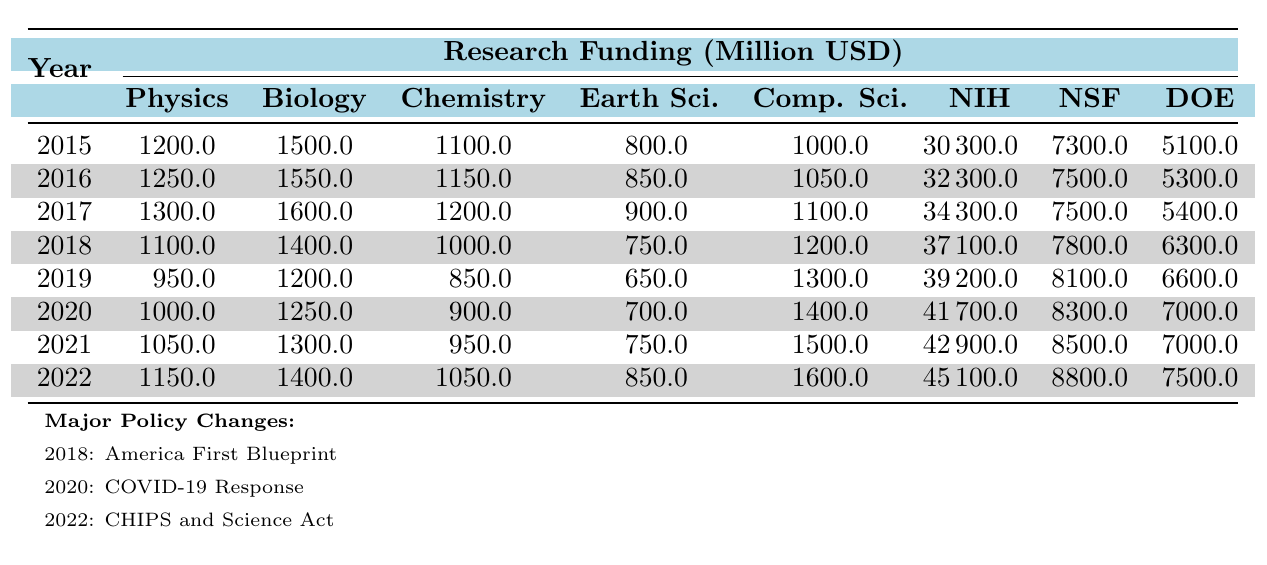What was the funding for Biology in 2020? In the table, the value for Biology Funding in 2020 is 1250 million USD.
Answer: 1250 million USD Which discipline received the highest funding in 2019? By comparing the funding values for 2019, Biology (1200 million USD) received the highest funding compared to other disciplines.
Answer: Biology What is the difference in funding for Physics between 2015 and 2022? The funding for Physics in 2015 was 1200 million USD, and in 2022 it was 1150 million USD. The difference is 1200 - 1150 = 50 million USD.
Answer: 50 million USD What was the average funding for Computer Science from 2015 to 2022? The total funding for Computer Science over these years is 1000 + 1050 + 1100 + 1200 + 1300 + 1400 + 1500 + 1600 = 10500 million USD. There are 8 years, so the average is 10500 / 8 = 1312.5 million USD.
Answer: 1312.5 million USD Did the funding for Earth Sciences increase from 2015 to 2022? In 2015, funding was 800 million USD, and in 2022 it was 850 million USD. Since 850 > 800, the funding did increase.
Answer: Yes Which major policy change corresponds to the year with the lowest Chemistry funding? The lowest Chemistry funding occurred in 2019 (850 million USD), and there were no major policy changes in that year.
Answer: None What is the total funding for Biology over the years 2015 to 2022? The total funding for Biology from 2015 to 2022 is 1500 + 1550 + 1600 + 1400 + 1200 + 1250 + 1300 + 1400 = 1,400 million USD.
Answer: 1,400 million USD Was there a decrease in NIH budget from 2019 to 2020? The NIH budget in 2019 is 39.2 billion USD and in 2020 is 41.7 billion USD. Since 41.7 > 39.2, there was no decrease.
Answer: No In which year did the Computer Science funding first exceed 1500 million USD? In the table, the funding for Computer Science first exceeded 1500 million USD in 2021 when it was 1500 million USD.
Answer: 2021 What is the trend in funding for Earth Sciences from 2015 to 2022? The funding values from 2015 (800 million USD) to 2022 (850 million USD) show a gradual increase overall (750, 650, 700, 750, and back up to 850).
Answer: Gradual increase 